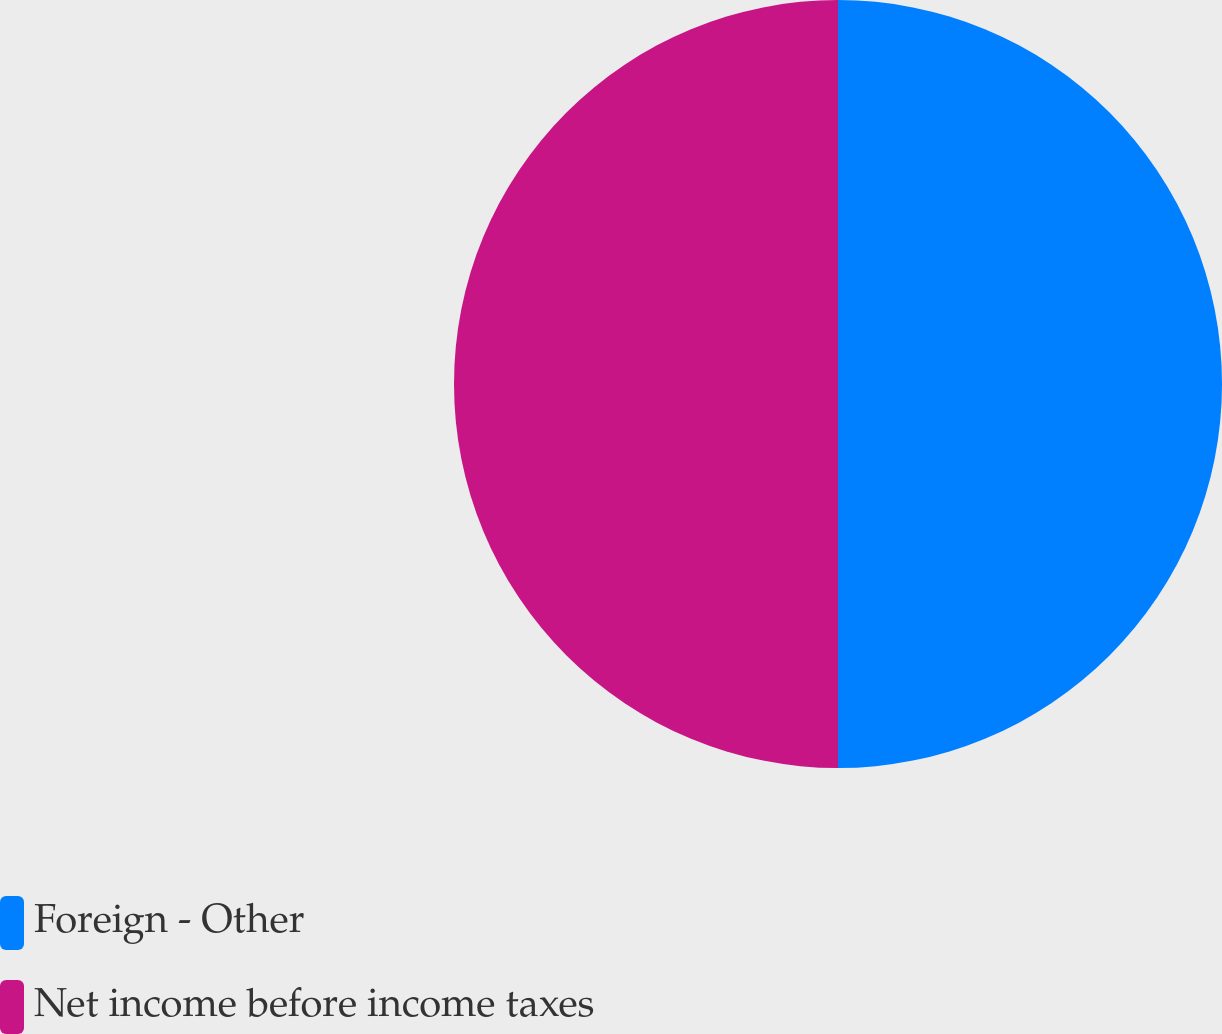Convert chart. <chart><loc_0><loc_0><loc_500><loc_500><pie_chart><fcel>Foreign - Other<fcel>Net income before income taxes<nl><fcel>50.0%<fcel>50.0%<nl></chart> 